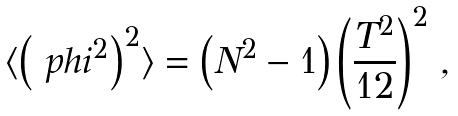<formula> <loc_0><loc_0><loc_500><loc_500>\langle \left ( \boldmath \ p h i ^ { 2 } \right ) ^ { 2 } \rangle = \left ( N ^ { 2 } - 1 \right ) \left ( \frac { T ^ { 2 } } { 1 2 } \right ) ^ { 2 } \, ,</formula> 